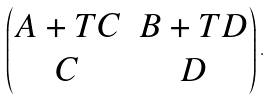<formula> <loc_0><loc_0><loc_500><loc_500>\begin{pmatrix} A + T C & B + T D \\ C & D \end{pmatrix} .</formula> 